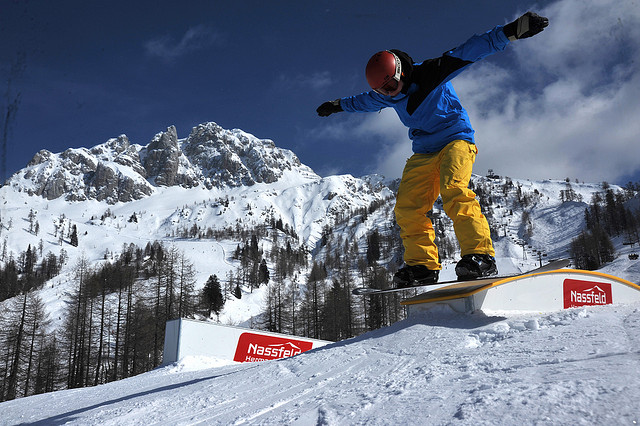Imagine the snowboarder lands perfectly. What might the subsequent actions be? Landing perfectly from the trick, the snowboarder would likely continue down the slope with increased momentum, seamlessly transitioning into another trick or navigating through the terrain with smooth precision. The successful execution would bring a rush of adrenaline and a boost of confidence, possibly drawing cheers from any distant onlookers. Upon reaching flatter ground, the snowboarder might pause for a moment to pump their fists in triumph, savoring the perfect run before heading back up for another exhilarating descent. 